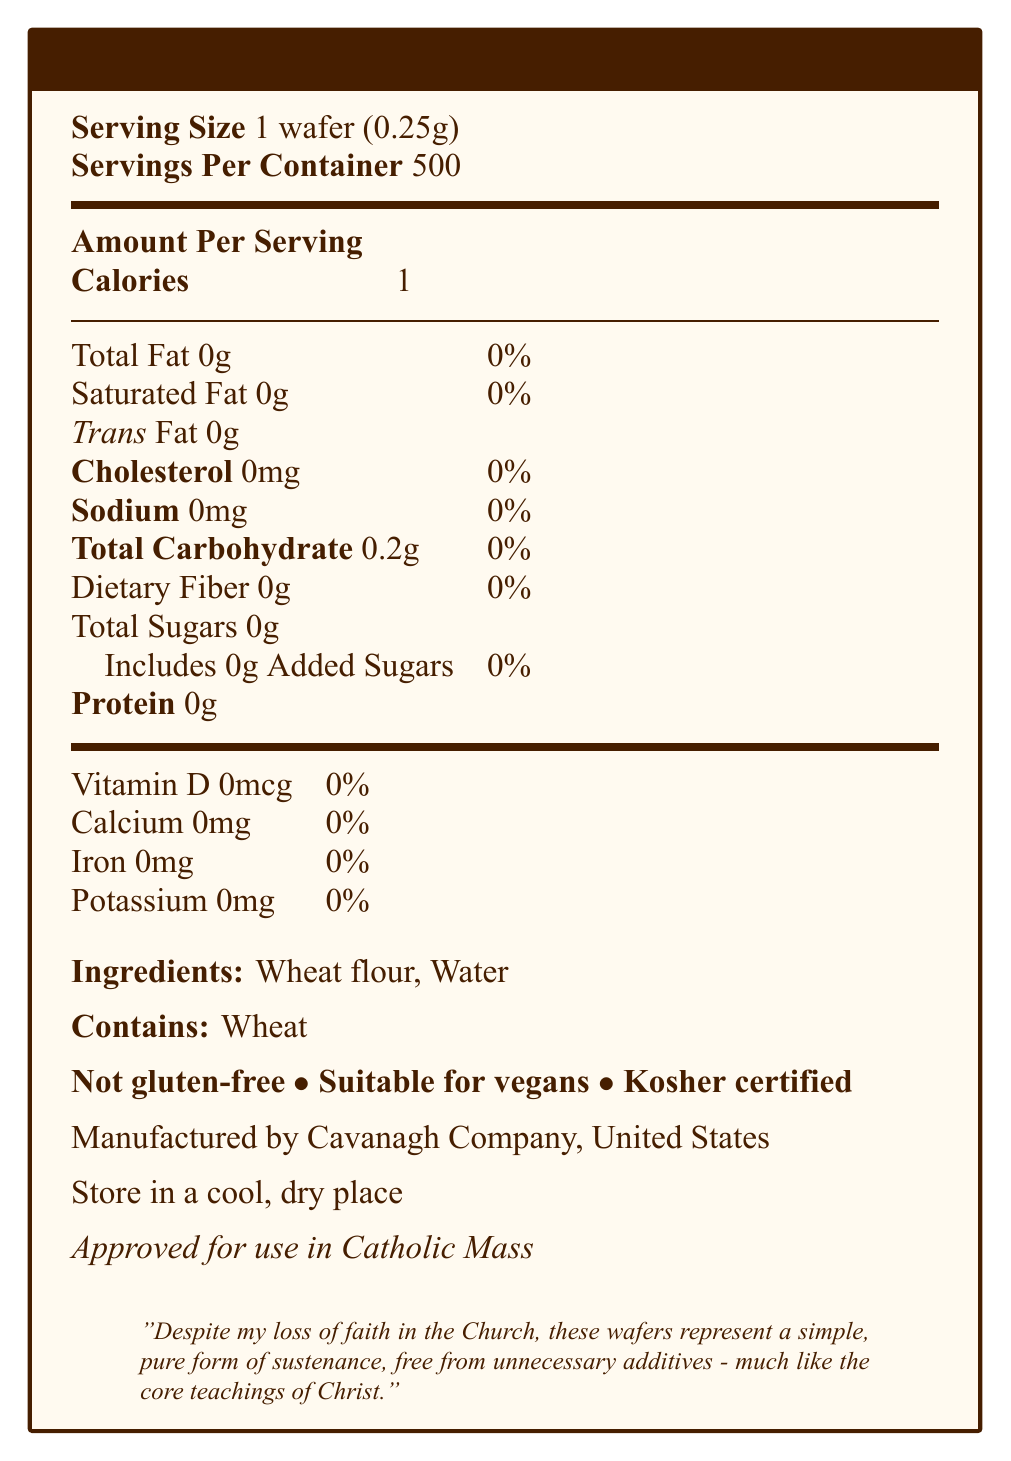What is the serving size of the communion wafer? The document specifies "Serving Size: 1 wafer (0.25g)" under the Nutrition Facts section.
Answer: 1 wafer (0.25g) How many servings are there per container? The document states "Servings Per Container: 500" near the top of the Nutrition Facts.
Answer: 500 How many calories are in one wafer? The calorie count listed in the document under "Calories" is 1 per serving.
Answer: 1 Which ingredients are used in the communion wafers? The Ingredients section lists "Wheat flour" and "Water".
Answer: Wheat flour, Water Is the product suitable for vegans? The suitability for vegans is stated directly with the phrase "Suitable for vegans".
Answer: Yes How much sodium is in one serving of the wafer? The Nutrition Facts table lists "Sodium 0mg" for each serving.
Answer: 0mg Which of the following is NOT found in the communion wafer? A. Cholesterol B. Dietary Fiber C. Trans Fat D. Iron Iron is listed as 0mg, but Dietary Fiber is found in the table with 0g.
Answer: B Where is the product manufactured? A. Italy B. United States C. Canada D. France The document specifies "Manufactured by Cavanagh Company, United States”.
Answer: B Is the communion wafer gluten-free? The document clearly mentions "Not gluten-free".
Answer: No Summarize the main idea of the document. The document displays detailed nutrition information, ingredient lists, and other food attributes. It emphasizes minimal ingredients, mentions allergen content, and contains a personal note reflecting on the spiritual significance despite a loss of faith.
Answer: The document provides detailed nutrition facts for communion wafers, including serving size, ingredients, allergen warnings, and suitability for specific diets. It also includes personal reflection on the purity and simplicity of the wafers. How much carbohydrate is in each serving? The document lists "Total Carbohydrate: 0.2g" under Nutrition Facts.
Answer: 0.2g Does the communion wafer contain any added sugars? "Added Sugars: 0g" is listed under the Total Sugars section in the document.
Answer: No What percentage of your daily vitamin D intake does one wafer provide? In the nutritional information, Vitamin D is listed as "0mcg 0%".
Answer: 0% What storage instructions are given for the wafers? The document specifies "Store in a cool, dry place".
Answer: Store in a cool, dry place What is the cholesterol content in one serving of the wafer? The Nutritional Facts show "Cholesterol: 0mg".
Answer: 0mg If one were allergic to wheat, could they consume this wafer? The allergen warning states "Contains wheat."
Answer: No What is the protein content in one serving? The document lists "Protein: 0g" in the Nutrition Facts.
Answer: 0g How many milligrams of calcium does one wafer have? The calcium content is listed as "0mg" in the nutritional section.
Answer: 0mg Who manufactures the communion wafers? The document mentions "Manufactured by Cavanagh Company" near the bottom.
Answer: Cavanagh Company What is the iron content per serving? The iron content is listed as "0mg" in the Nutrition Facts section.
Answer: 0mg What spiritual or personal reflection is included in the document? This quote is included in italics in the document as a personal reflection.
Answer: Despite my loss of faith in the Church, these wafers represent a simple, pure form of sustenance, free from unnecessary additives - much like the core teachings of Christ. Is the iron content in one wafer high or low? The document does not provide context to determine if the iron content is high or low. The absolute amount is 0mg, but there is no scale given.
Answer: Not enough information What is the Kosher status of the wafers? The document states "Kosher certified" near the bottom.
Answer: Kosher certified What is the main allergen mentioned in the document? Under allergen information, the document states "Contains wheat".
Answer: Wheat 